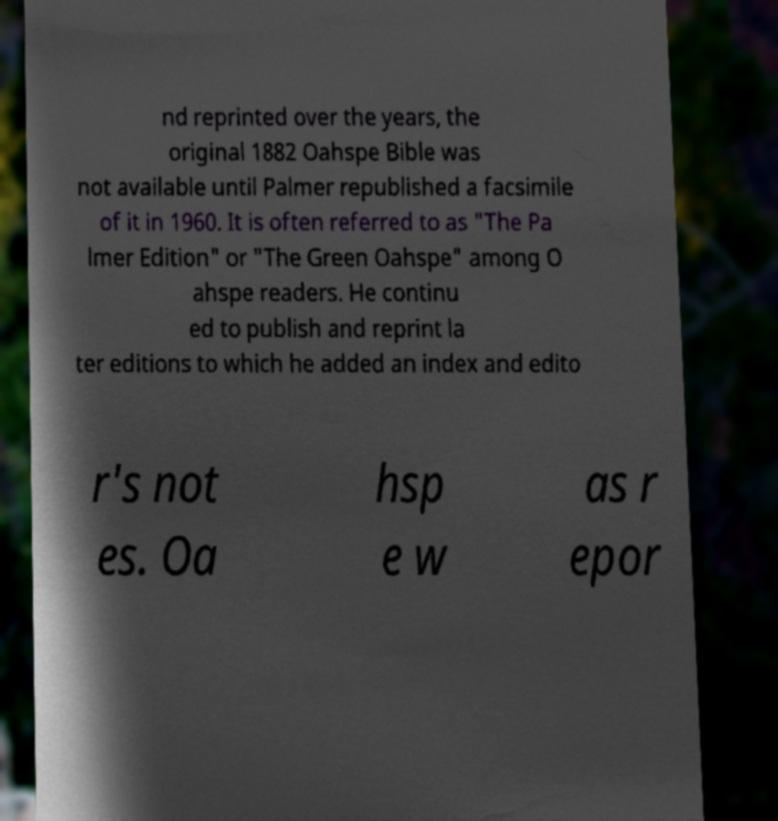For documentation purposes, I need the text within this image transcribed. Could you provide that? nd reprinted over the years, the original 1882 Oahspe Bible was not available until Palmer republished a facsimile of it in 1960. It is often referred to as "The Pa lmer Edition" or "The Green Oahspe" among O ahspe readers. He continu ed to publish and reprint la ter editions to which he added an index and edito r's not es. Oa hsp e w as r epor 